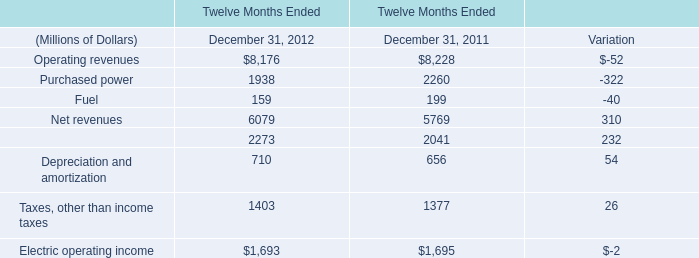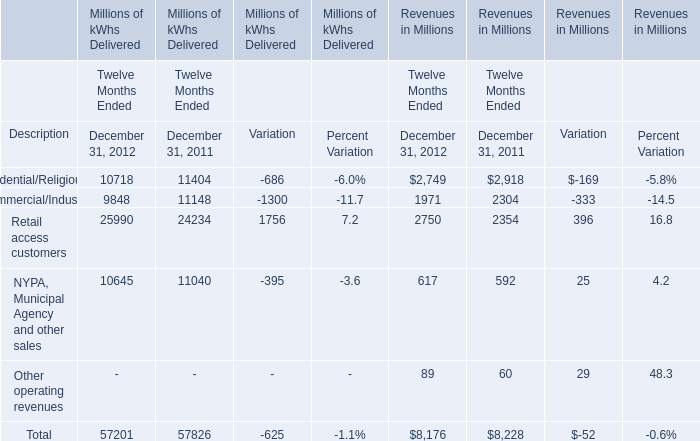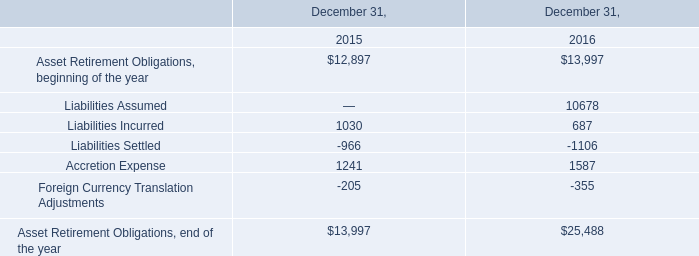What is the sum of Retail access customers of Millions of kWhs Delivered Variation, Purchased power of Twelve Months Ended December 31, 2012, and Retail access customers of Revenues in Millions Twelve Months Ended December 31, 2011 ? 
Computations: ((1756.0 + 1938.0) + 2354.0)
Answer: 6048.0. 